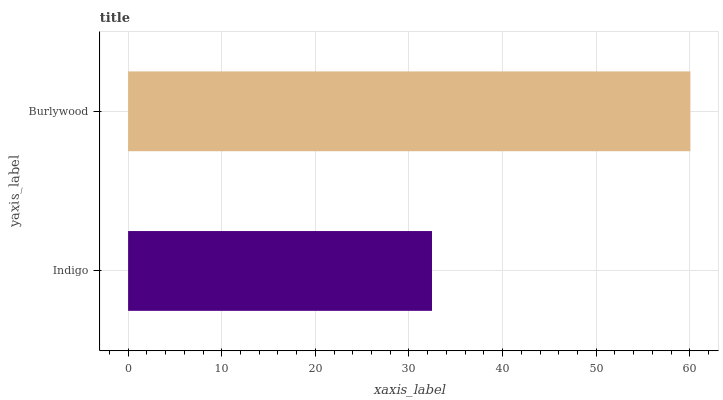Is Indigo the minimum?
Answer yes or no. Yes. Is Burlywood the maximum?
Answer yes or no. Yes. Is Burlywood the minimum?
Answer yes or no. No. Is Burlywood greater than Indigo?
Answer yes or no. Yes. Is Indigo less than Burlywood?
Answer yes or no. Yes. Is Indigo greater than Burlywood?
Answer yes or no. No. Is Burlywood less than Indigo?
Answer yes or no. No. Is Burlywood the high median?
Answer yes or no. Yes. Is Indigo the low median?
Answer yes or no. Yes. Is Indigo the high median?
Answer yes or no. No. Is Burlywood the low median?
Answer yes or no. No. 